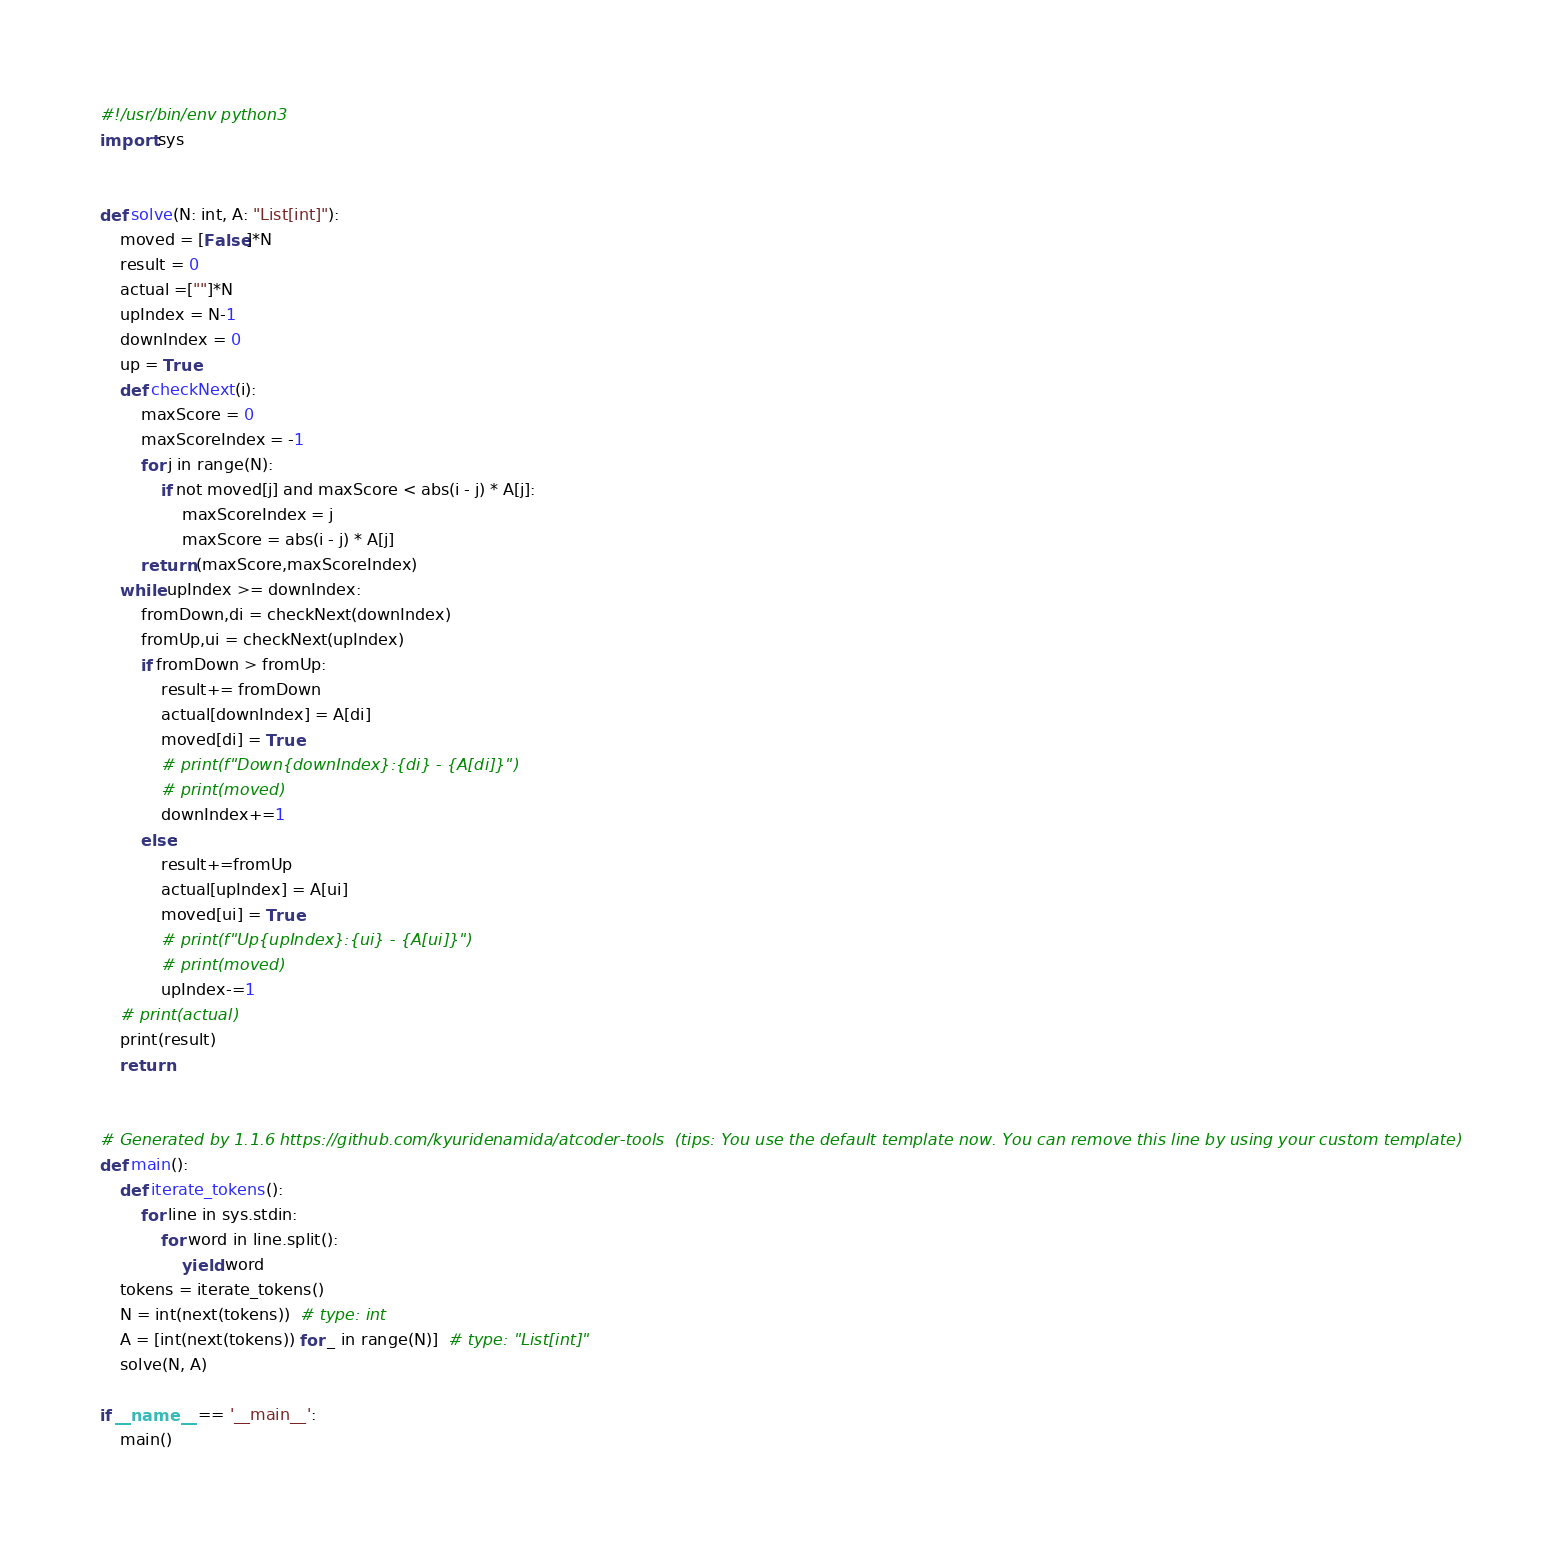Convert code to text. <code><loc_0><loc_0><loc_500><loc_500><_Python_>#!/usr/bin/env python3
import sys


def solve(N: int, A: "List[int]"):
    moved = [False]*N
    result = 0
    actual =[""]*N
    upIndex = N-1
    downIndex = 0
    up = True
    def checkNext(i):
        maxScore = 0
        maxScoreIndex = -1
        for j in range(N):
            if not moved[j] and maxScore < abs(i - j) * A[j]:
                maxScoreIndex = j
                maxScore = abs(i - j) * A[j]
        return (maxScore,maxScoreIndex)
    while upIndex >= downIndex:
        fromDown,di = checkNext(downIndex)
        fromUp,ui = checkNext(upIndex)
        if fromDown > fromUp:
            result+= fromDown
            actual[downIndex] = A[di]
            moved[di] = True
            # print(f"Down{downIndex}:{di} - {A[di]}")
            # print(moved)
            downIndex+=1
        else:
            result+=fromUp
            actual[upIndex] = A[ui]
            moved[ui] = True
            # print(f"Up{upIndex}:{ui} - {A[ui]}")
            # print(moved)
            upIndex-=1
    # print(actual)
    print(result)
    return


# Generated by 1.1.6 https://github.com/kyuridenamida/atcoder-tools  (tips: You use the default template now. You can remove this line by using your custom template)
def main():
    def iterate_tokens():
        for line in sys.stdin:
            for word in line.split():
                yield word
    tokens = iterate_tokens()
    N = int(next(tokens))  # type: int
    A = [int(next(tokens)) for _ in range(N)]  # type: "List[int]"
    solve(N, A)

if __name__ == '__main__':
    main()
</code> 